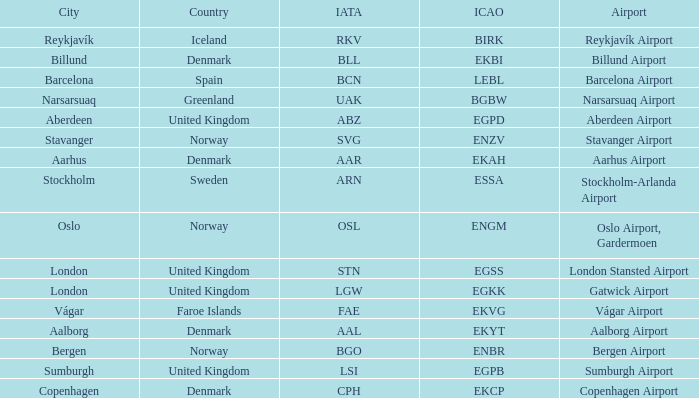What airport has an IATA of ARN? Stockholm-Arlanda Airport. 